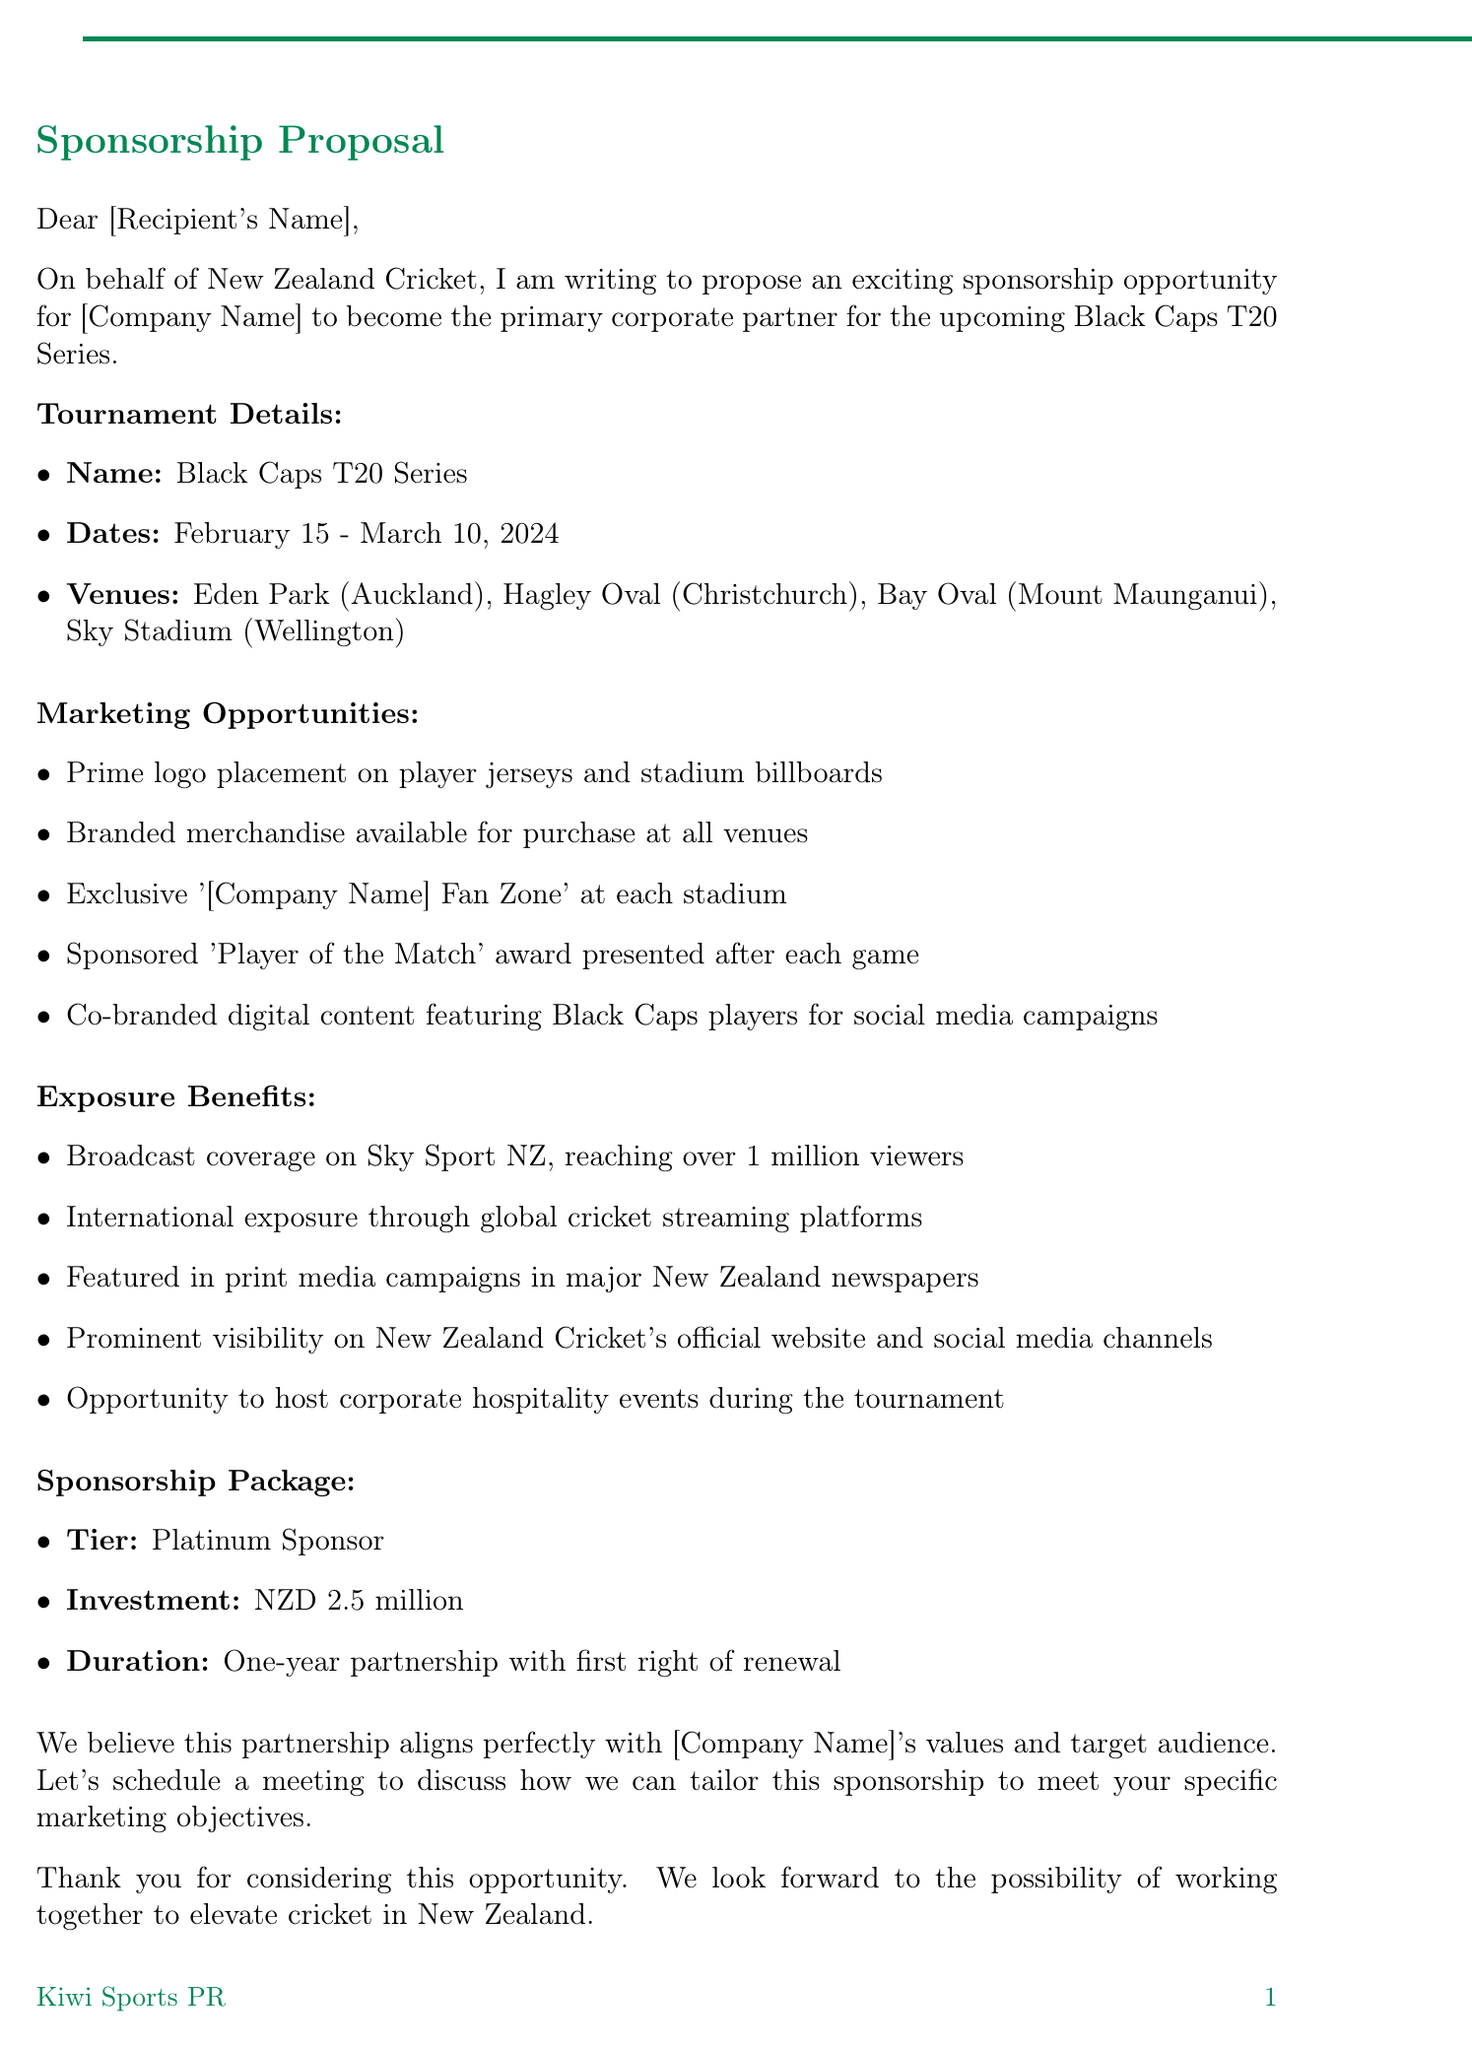What are the dates of the Black Caps T20 Series? The dates for the Black Caps T20 Series are explicitly stated in the document.
Answer: February 15 - March 10, 2024 What is the investment amount for the Platinum Sponsor tier? The investment amount for the Platinum Sponsor tier is mentioned under the sponsorship package section.
Answer: NZD 2.5 million What is one of the marketing opportunities highlighted in the letter? The letter lists several marketing opportunities, and one can be easily recalled.
Answer: Prime logo placement on player jerseys and stadium billboards Who is the Senior Sponsorship Manager? The document includes a signature section that identifies this role.
Answer: Jane Thompson What is one benefit of exposure mentioned in the document? The exposure benefits are listed, and one of them can be selected based on the listings.
Answer: Broadcast coverage on Sky Sport NZ How does this partnership align with the company’s values? The letter states that the partnership aligns perfectly with the company's values and target audience, indicating reasoning is needed.
Answer: Partnership aligns perfectly with [Company Name]'s values What is the duration of the sponsorship package? The duration of the sponsorship package is clearly defined in the document.
Answer: One-year partnership with first right of renewal What is the call to action in the letter? The letter concludes with a specific call to action regarding the potential partnership.
Answer: Let's schedule a meeting to discuss What additional context is provided about New Zealand Cricket's recent success? The document references a notable achievement by New Zealand Cricket that enhances its credibility.
Answer: New Zealand's victory in the ICC World Test Championship 